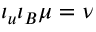<formula> <loc_0><loc_0><loc_500><loc_500>\iota _ { u } \iota _ { B } \mu = \nu</formula> 